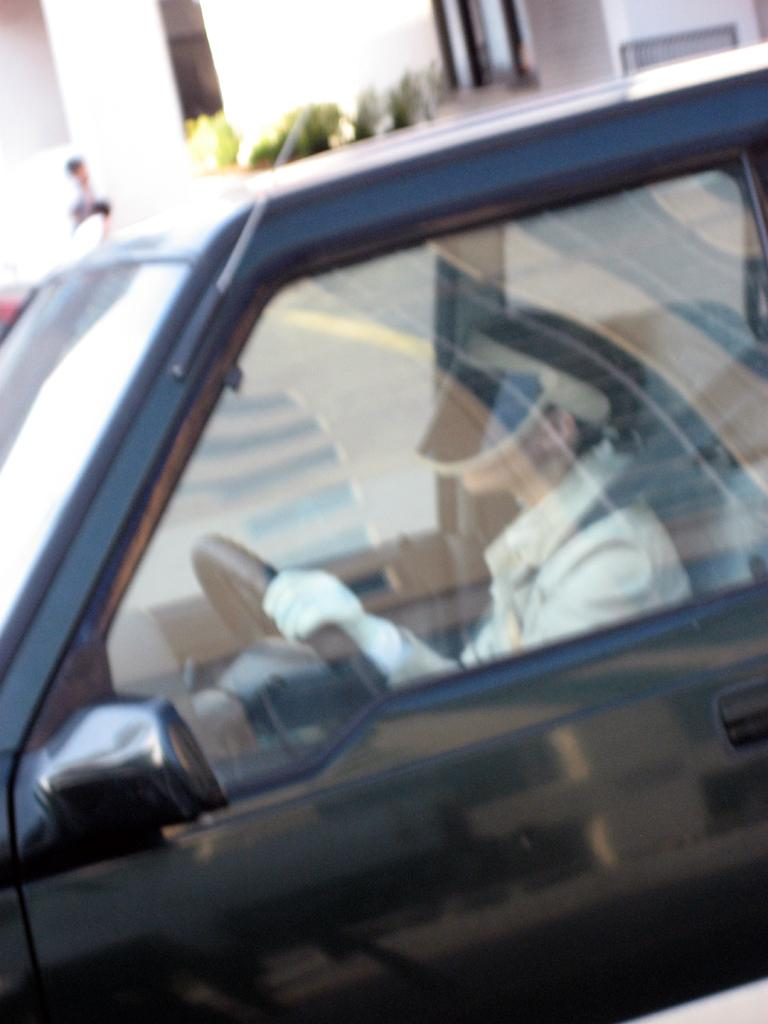What is the person in the image doing? The person is seated in a car. What can be seen in the background of the image? There are plants and a building in the background of the image. What language is the person speaking in the image? There is no indication of the person speaking in the image, so it cannot be determined what language they might be using. 